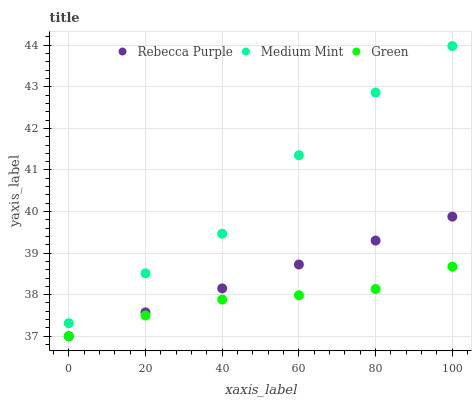Does Green have the minimum area under the curve?
Answer yes or no. Yes. Does Medium Mint have the maximum area under the curve?
Answer yes or no. Yes. Does Rebecca Purple have the minimum area under the curve?
Answer yes or no. No. Does Rebecca Purple have the maximum area under the curve?
Answer yes or no. No. Is Rebecca Purple the smoothest?
Answer yes or no. Yes. Is Medium Mint the roughest?
Answer yes or no. Yes. Is Green the smoothest?
Answer yes or no. No. Is Green the roughest?
Answer yes or no. No. Does Green have the lowest value?
Answer yes or no. Yes. Does Medium Mint have the highest value?
Answer yes or no. Yes. Does Rebecca Purple have the highest value?
Answer yes or no. No. Is Green less than Medium Mint?
Answer yes or no. Yes. Is Medium Mint greater than Rebecca Purple?
Answer yes or no. Yes. Does Green intersect Rebecca Purple?
Answer yes or no. Yes. Is Green less than Rebecca Purple?
Answer yes or no. No. Is Green greater than Rebecca Purple?
Answer yes or no. No. Does Green intersect Medium Mint?
Answer yes or no. No. 